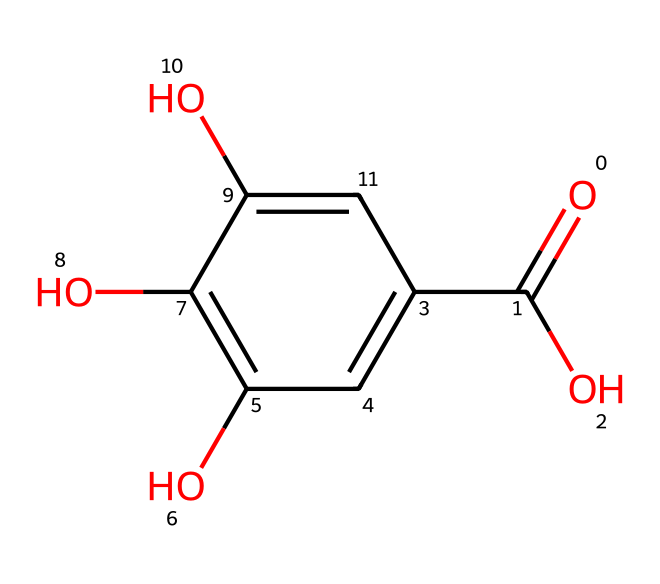What is the functional group present in this chemical? The chemical has a carboxylic acid group, characterized by the -COOH structure at one end. This can be identified by observing the presence of a carbon atom double-bonded to an oxygen (indicating a carbonyl) and single-bonded to a hydroxyl group (indicating the acidic nature).
Answer: carboxylic acid How many hydroxyl groups are present in this structure? The structure shows three -OH (hydroxyl) groups attached to the aromatic ring, indicated by the presence of three oxygen atoms connected to hydrogen within the molecule. Each hydroxyl group contributes to the polarity and solubility characteristics of the dye.
Answer: three What type of chemical is this based on its structure? The presence of multiple hydroxyl groups and the carboxylic acid indicates that this chemical is a phenolic compound, as it consists of a benzene ring combined with hydroxyl functionalities. These characteristics are common in natural dyes, particularly those derived from plant sources.
Answer: phenolic What is the molecular formula derived from this chemical structure? By analyzing the atoms in the structure, there are 15 carbons, 10 hydrogens, and 5 oxygens. Counting each atom associated with the given SMILES provides the total number, which combines to form the molecular formula C15H10O5.
Answer: C15H10O5 What does the presence of multiple hydroxyl groups indicate about the solubility of this compound? Having multiple hydroxyl groups increases the compound's ability to form hydrogen bonds with water, which typically leads to increased solubility in polar solvents. The polar nature of these groups makes the compound better able to interact with water molecules.
Answer: increased solubility Which part of this structure contributes to its color properties? The chromophore region typically responsible for the dye's color in organic compounds is often linked to the presence of conjugated double bonds or aromatic systems, which in this case can be attributed to the aromatic ring. This arrangement affects light absorption and thus color.
Answer: aromatic ring 